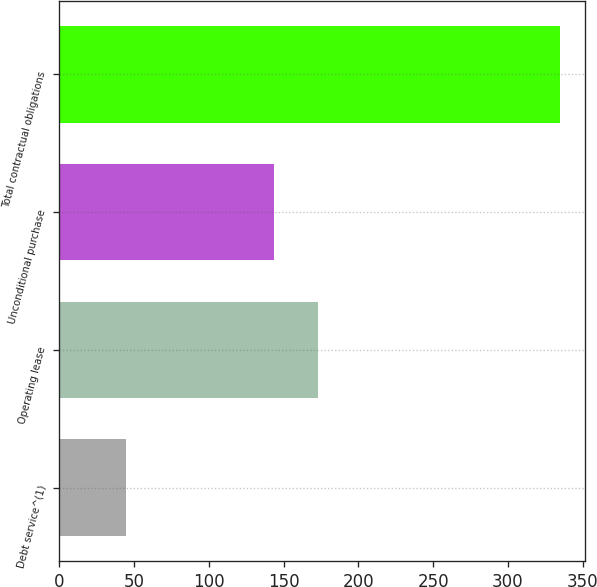<chart> <loc_0><loc_0><loc_500><loc_500><bar_chart><fcel>Debt service^(1)<fcel>Operating lease<fcel>Unconditional purchase<fcel>Total contractual obligations<nl><fcel>44.7<fcel>172.79<fcel>143.8<fcel>334.6<nl></chart> 